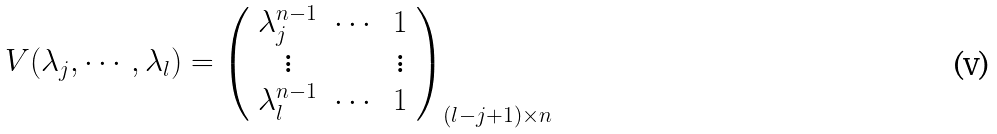Convert formula to latex. <formula><loc_0><loc_0><loc_500><loc_500>V ( \lambda _ { j } , \cdots , \lambda _ { l } ) = \left ( \begin{array} { c c c } \lambda _ { j } ^ { n - 1 } & \cdots & 1 \\ \vdots & & \vdots \\ \lambda _ { l } ^ { n - 1 } & \cdots & 1 \end{array} \right ) _ { ( l - j + 1 ) \times n }</formula> 